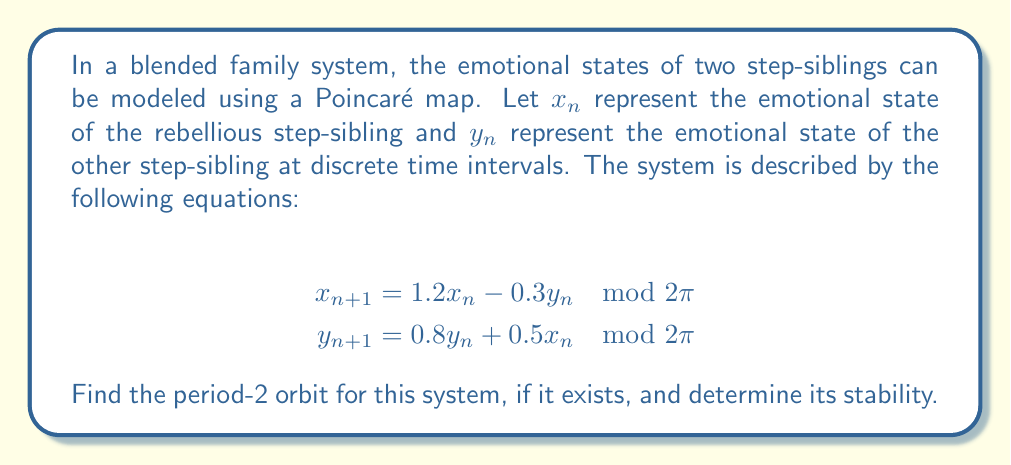What is the answer to this math problem? To find the period-2 orbit, we need to solve the following equations:

$$x_{n+2} = x_n \mod 2\pi$$
$$y_{n+2} = y_n \mod 2\pi$$

Step 1: Express $x_{n+2}$ and $y_{n+2}$ in terms of $x_n$ and $y_n$:
$$x_{n+2} = 1.2(1.2x_n - 0.3y_n) - 0.3(0.8y_n + 0.5x_n) \mod 2\pi$$
$$y_{n+2} = 0.8(0.8y_n + 0.5x_n) + 0.5(1.2x_n - 0.3y_n) \mod 2\pi$$

Step 2: Simplify the equations:
$$x_{n+2} = 1.29x_n - 0.6y_n \mod 2\pi$$
$$y_{n+2} = 1.04x_n + 0.52y_n \mod 2\pi$$

Step 3: Set up the system of equations for the period-2 orbit:
$$1.29x_n - 0.6y_n = x_n \mod 2\pi$$
$$1.04x_n + 0.52y_n = y_n \mod 2\pi$$

Step 4: Solve the system of equations:
$$0.29x_n - 0.6y_n = 0 \mod 2\pi$$
$$1.04x_n - 0.48y_n = 0 \mod 2\pi$$

Dividing the second equation by 1.04, we get:
$$x_n - 0.4615y_n = 0 \mod 2\pi$$

This is inconsistent with the first equation, indicating that there is no non-trivial period-2 orbit for this system.

Step 5: Check stability of the trivial fixed point (0, 0):
The Jacobian matrix at (0, 0) is:
$$J = \begin{bmatrix} 1.2 & -0.3 \\ 0.5 & 0.8 \end{bmatrix}$$

The eigenvalues of J are approximately 1.3416 and 0.6584.

Since one eigenvalue is greater than 1 in magnitude, the trivial fixed point is unstable.
Answer: No non-trivial period-2 orbit exists. The trivial fixed point (0, 0) is unstable. 